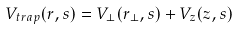<formula> <loc_0><loc_0><loc_500><loc_500>V _ { t r a p } ( r , s ) = V _ { \bot } ( r _ { \bot } , s ) + V _ { z } ( z , s )</formula> 